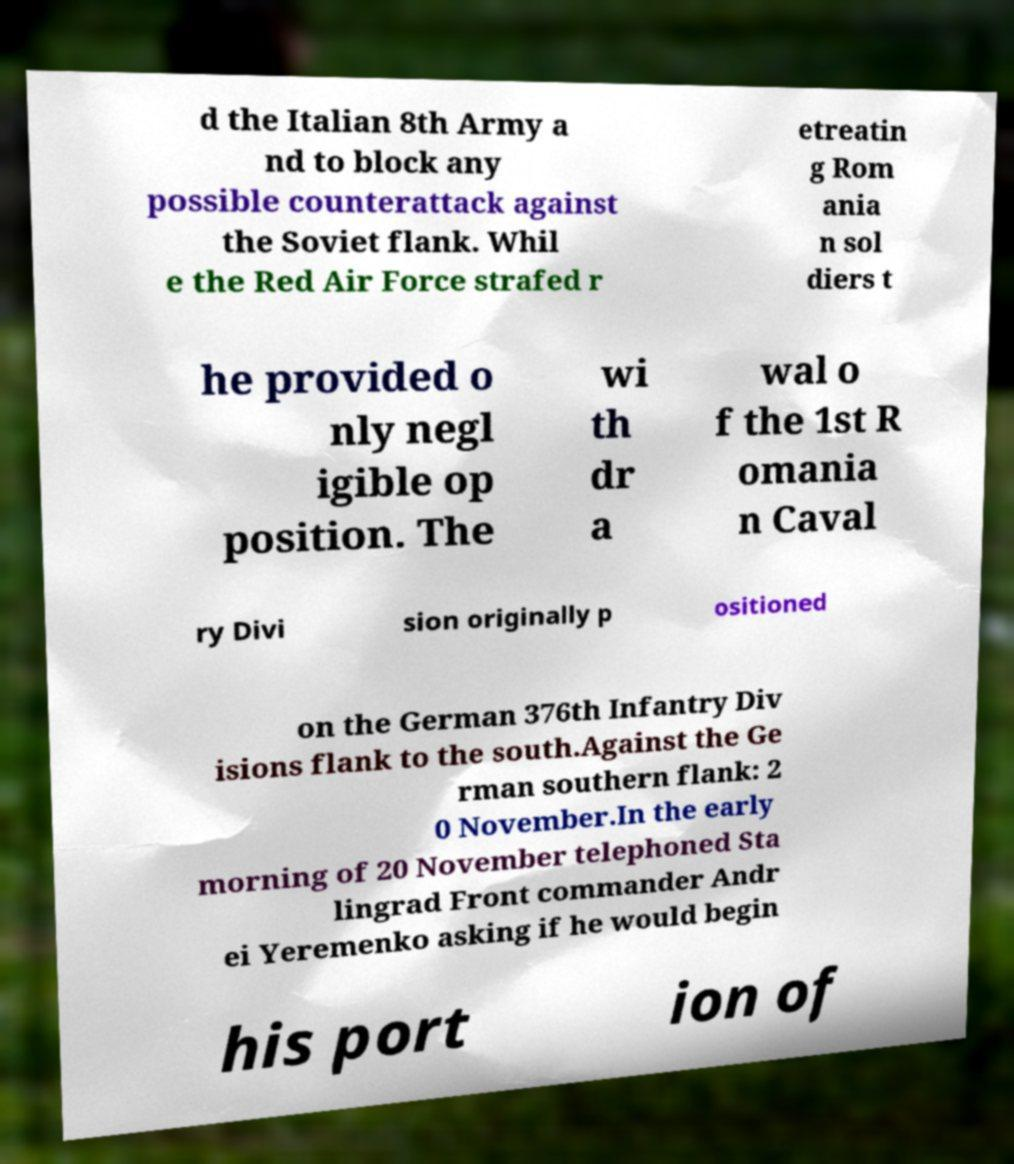Can you read and provide the text displayed in the image?This photo seems to have some interesting text. Can you extract and type it out for me? d the Italian 8th Army a nd to block any possible counterattack against the Soviet flank. Whil e the Red Air Force strafed r etreatin g Rom ania n sol diers t he provided o nly negl igible op position. The wi th dr a wal o f the 1st R omania n Caval ry Divi sion originally p ositioned on the German 376th Infantry Div isions flank to the south.Against the Ge rman southern flank: 2 0 November.In the early morning of 20 November telephoned Sta lingrad Front commander Andr ei Yeremenko asking if he would begin his port ion of 